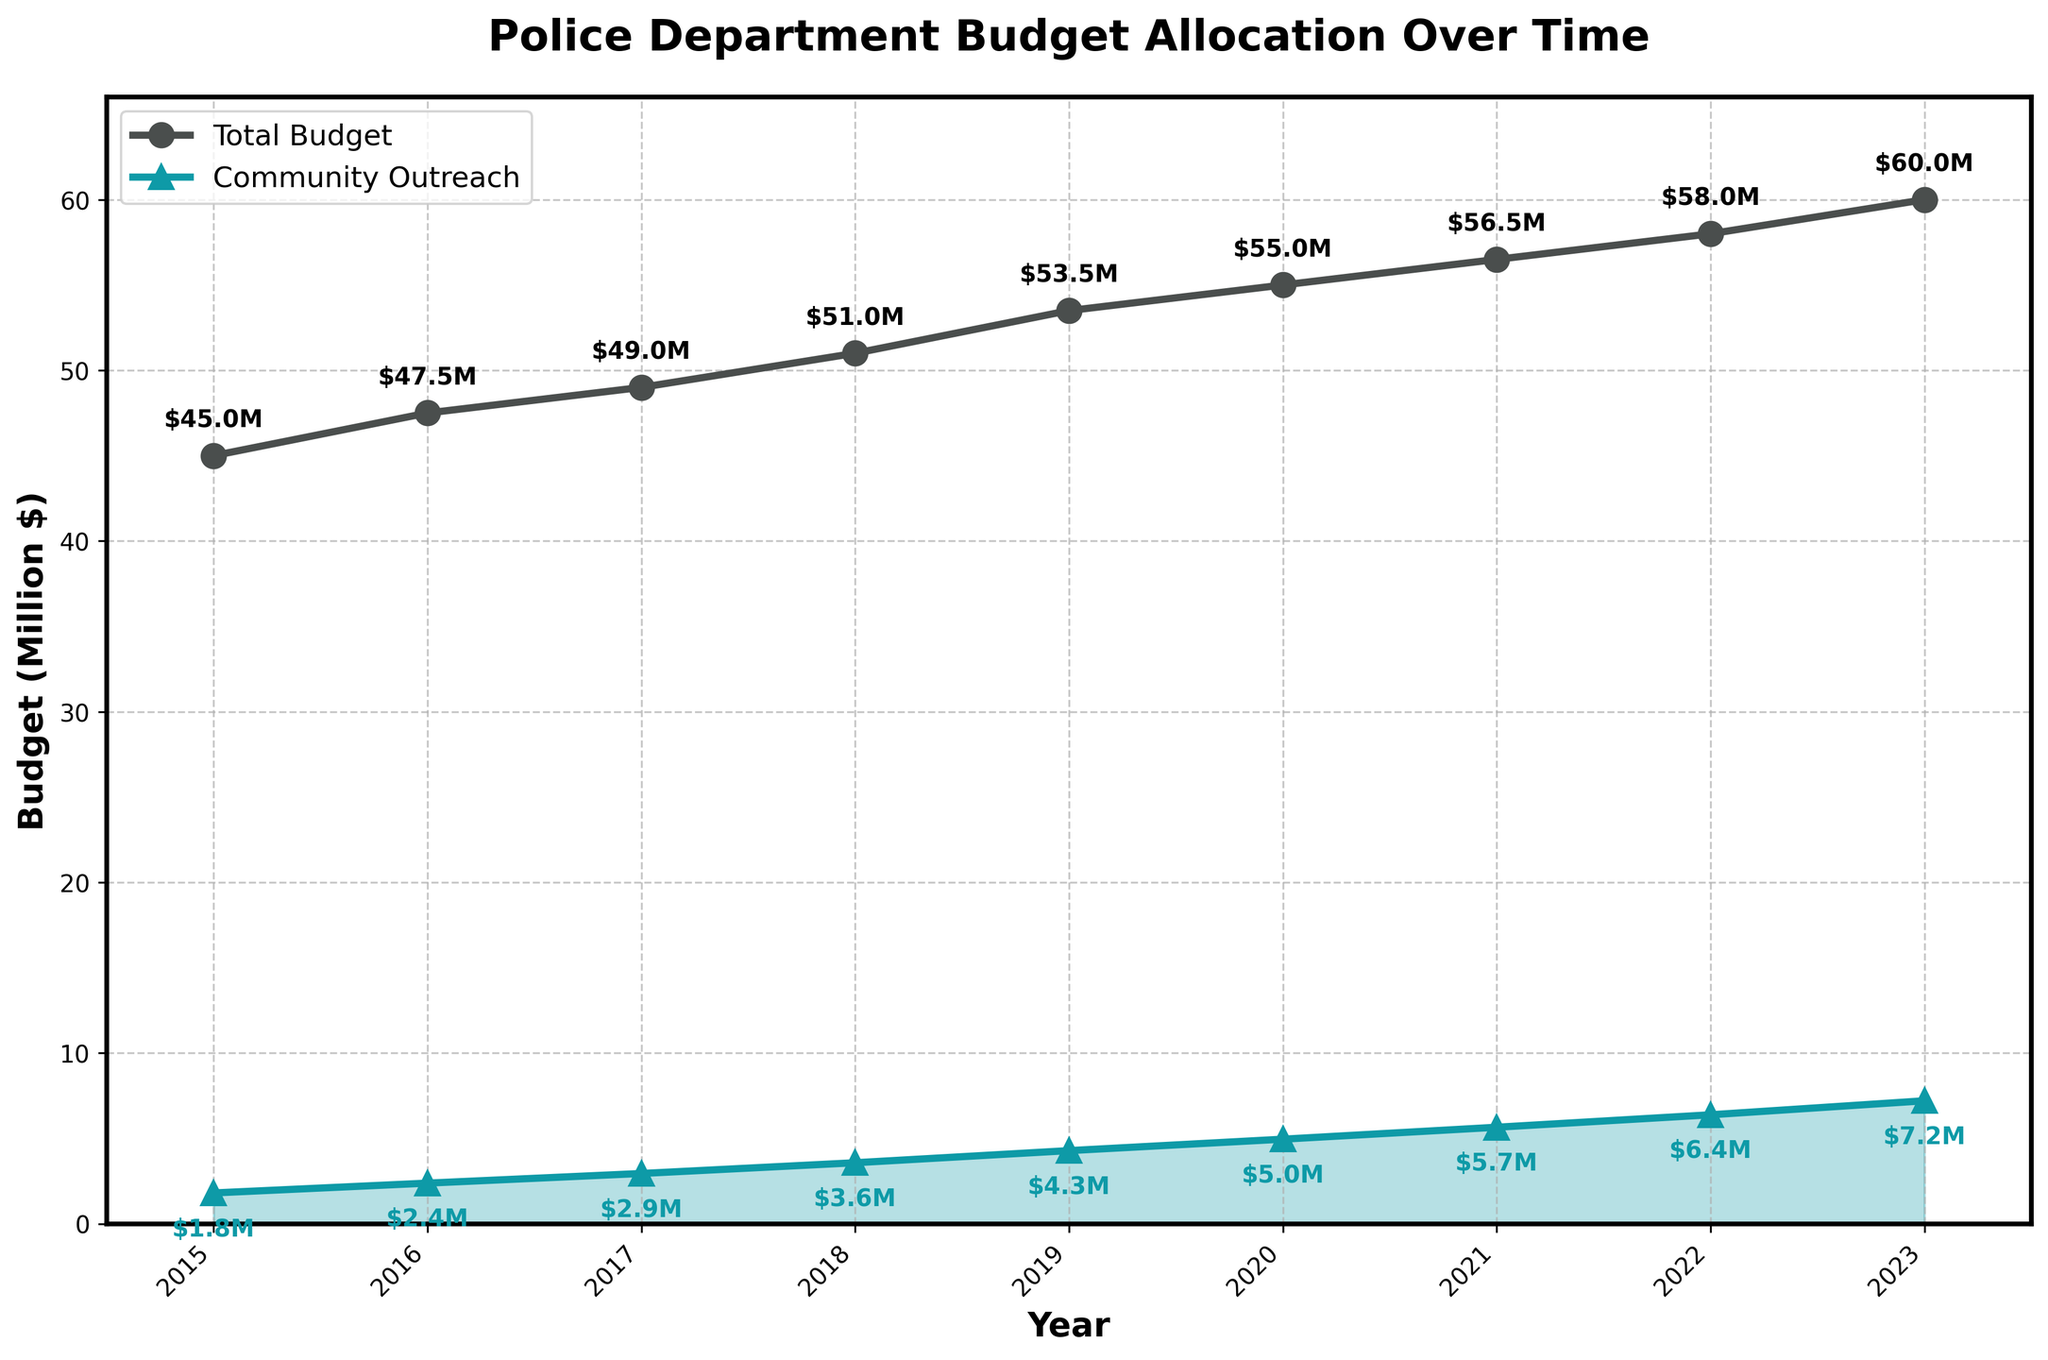What's the total increase in the police department budget from 2015 to 2023? The total budget in 2015 was $45 million, and in 2023, it was $60 million. The increase is $60 million - $45 million = $15 million.
Answer: $15 million What percentage of the total budget was allocated to community outreach programs in 2023? The total budget in 2023 was $60 million, and the community outreach budget was $7.2 million. The percentage is ($7.2 million / $60 million) * 100%.
Answer: 12% How much more was allocated to community outreach in 2022 than in 2017? The community outreach budget in 2022 was $6.38 million, and in 2017, it was $2.94 million. The difference is $6.38 million - $2.94 million = $3.44 million.
Answer: $3.44 million Which year saw the largest increase in the community outreach budget from the previous year? From the figure, observe the year-to-year increases: 2015-2016: $0.575 million, 2016-2017: $0.565 million, 2017-2018: $0.63 million, 2018-2019: $0.71 million, 2019-2020: $0.67 million, 2020-2021: $0.7 million, 2021-2022: $0.73 million, 2022-2023: $0.82 million. The largest increase was from 2022 to 2023.
Answer: 2023 In which year did the budget for community outreach first exceed $3 million? From the figure, the budget for community outreach first exceeded $3 million in 2018, with a value of $3.57 million.
Answer: 2018 Comparing 2015 and 2023, by how many million dollars did the budget for community outreach grow? The community outreach budget in 2015 was $1.8 million, and in 2023, it was $7.2 million. The growth is $7.2 million - $1.8 million = $5.4 million.
Answer: $5.4 million What is the average annual budget for community outreach from 2015 to 2023? Sum the annual community outreach budgets: $1.8M + $2.375M + $2.94M + $3.57M + $4.28M + $4.95M + $5.65M + $6.38M + $7.2M = $39.145M. Divide by the number of years (9): $39.145M / 9 ≈ $4.35M.
Answer: $4.35 million How does the trend of the total budget compare to the trend of community outreach funding over the years? Both the total budget and community outreach funding show an increasing trend from 2015 to 2023, with community outreach funding growing at a higher rate relative to its initial value.
Answer: Increasing trends Which year had the smallest difference between the total budget and the community outreach budget? The smallest difference is seen where the total budget and community outreach budget are closest to each other. In 2021, the difference was $56.5M - $5.65M = $50.85M, which is the minimal difference observed.
Answer: 2021 